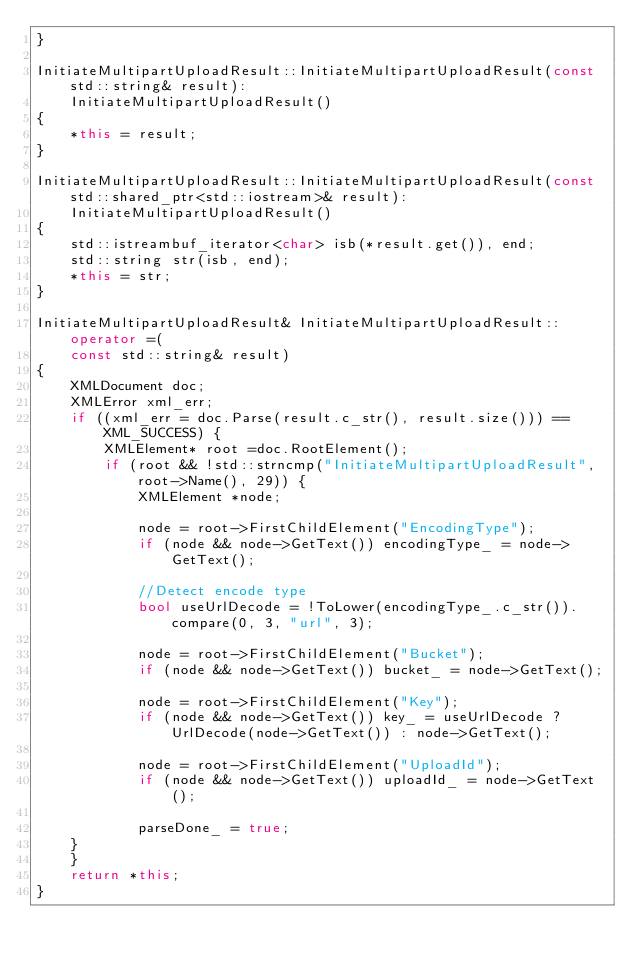Convert code to text. <code><loc_0><loc_0><loc_500><loc_500><_C++_>}

InitiateMultipartUploadResult::InitiateMultipartUploadResult(const std::string& result):
    InitiateMultipartUploadResult()
{
    *this = result;
}

InitiateMultipartUploadResult::InitiateMultipartUploadResult(const std::shared_ptr<std::iostream>& result):
    InitiateMultipartUploadResult()
{
    std::istreambuf_iterator<char> isb(*result.get()), end;
    std::string str(isb, end);
    *this = str;
}

InitiateMultipartUploadResult& InitiateMultipartUploadResult::operator =(
    const std::string& result)
{
    XMLDocument doc;
    XMLError xml_err;
    if ((xml_err = doc.Parse(result.c_str(), result.size())) == XML_SUCCESS) {
        XMLElement* root =doc.RootElement();
        if (root && !std::strncmp("InitiateMultipartUploadResult", root->Name(), 29)) {
            XMLElement *node;

            node = root->FirstChildElement("EncodingType");
            if (node && node->GetText()) encodingType_ = node->GetText();

            //Detect encode type
            bool useUrlDecode = !ToLower(encodingType_.c_str()).compare(0, 3, "url", 3);

            node = root->FirstChildElement("Bucket");
            if (node && node->GetText()) bucket_ = node->GetText();

            node = root->FirstChildElement("Key");
            if (node && node->GetText()) key_ = useUrlDecode ? UrlDecode(node->GetText()) : node->GetText();

            node = root->FirstChildElement("UploadId");
            if (node && node->GetText()) uploadId_ = node->GetText();

            parseDone_ = true;
		}
    }
    return *this;
}
</code> 